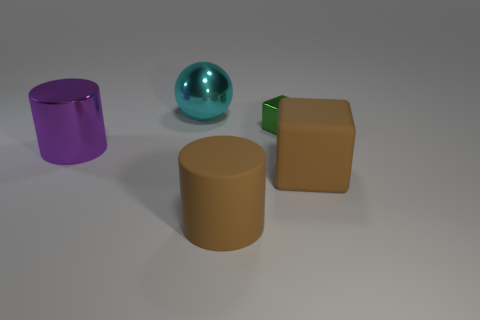Add 1 big yellow matte spheres. How many objects exist? 6 Subtract all balls. How many objects are left? 4 Subtract all red cylinders. Subtract all gray balls. How many cylinders are left? 2 Subtract all brown spheres. How many brown blocks are left? 1 Subtract all tiny brown rubber cylinders. Subtract all purple shiny things. How many objects are left? 4 Add 1 large metallic things. How many large metallic things are left? 3 Add 3 tiny blocks. How many tiny blocks exist? 4 Subtract 0 yellow blocks. How many objects are left? 5 Subtract 1 cubes. How many cubes are left? 1 